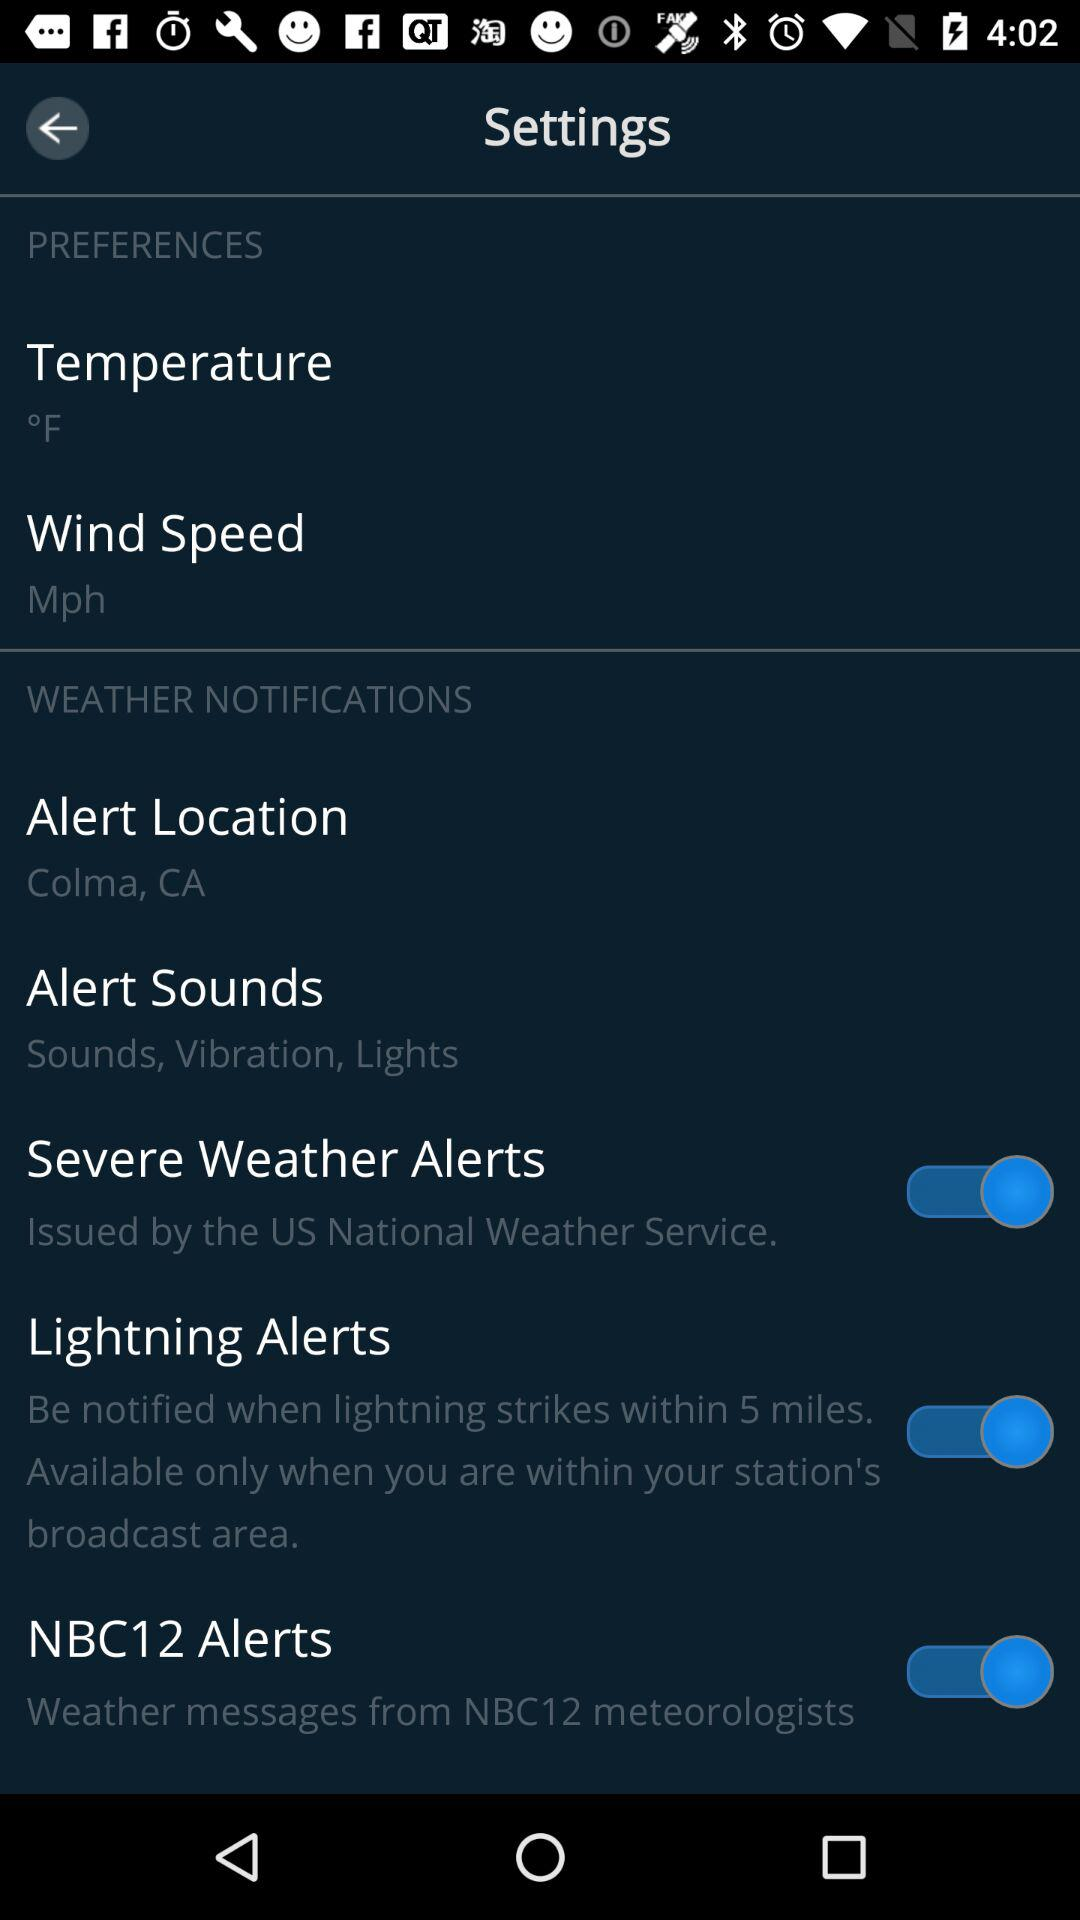What is the unit of temperature? The unit of temperature is degree Fahrenheit. 